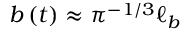<formula> <loc_0><loc_0><loc_500><loc_500>b \left ( t \right ) \approx \pi ^ { - 1 / 3 } \ell _ { b }</formula> 